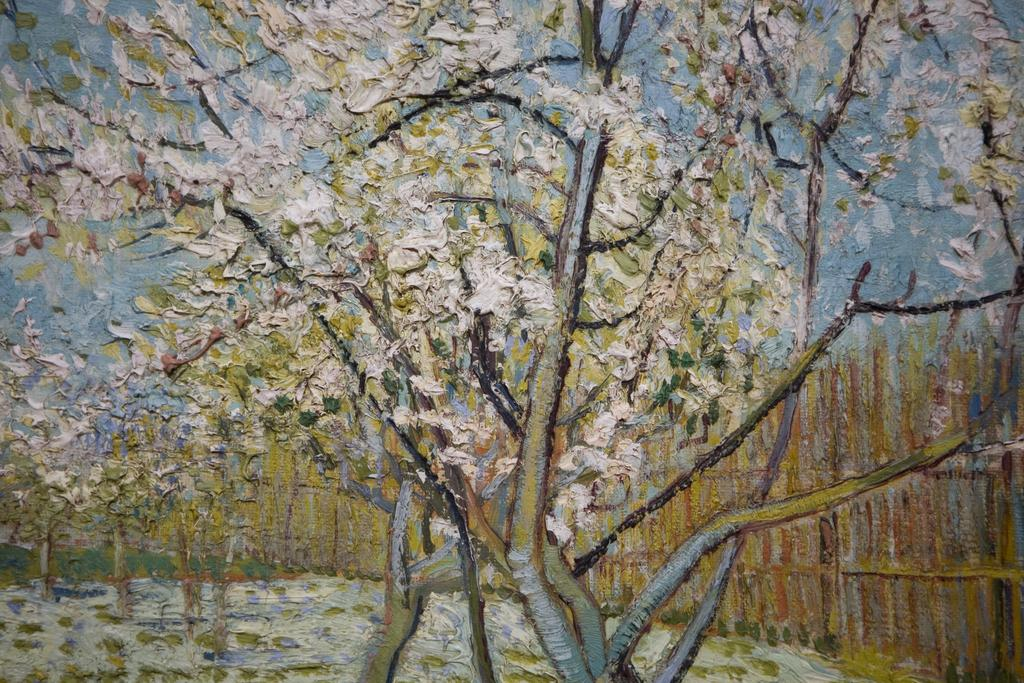What is present in the image? There is a paper in the image. What is depicted on the paper? The paper has a painting on it. What type of juice can be seen spilling on the paper in the image? There is no juice present in the image; it only features a paper with a painting on it. 